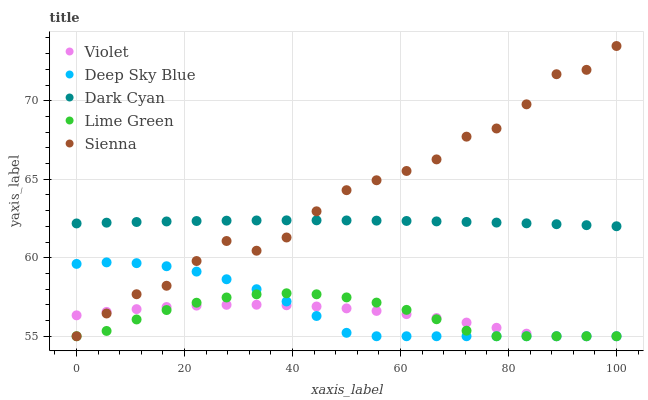Does Violet have the minimum area under the curve?
Answer yes or no. Yes. Does Sienna have the maximum area under the curve?
Answer yes or no. Yes. Does Lime Green have the minimum area under the curve?
Answer yes or no. No. Does Lime Green have the maximum area under the curve?
Answer yes or no. No. Is Dark Cyan the smoothest?
Answer yes or no. Yes. Is Sienna the roughest?
Answer yes or no. Yes. Is Lime Green the smoothest?
Answer yes or no. No. Is Lime Green the roughest?
Answer yes or no. No. Does Sienna have the lowest value?
Answer yes or no. Yes. Does Sienna have the highest value?
Answer yes or no. Yes. Does Lime Green have the highest value?
Answer yes or no. No. Is Deep Sky Blue less than Dark Cyan?
Answer yes or no. Yes. Is Dark Cyan greater than Deep Sky Blue?
Answer yes or no. Yes. Does Dark Cyan intersect Sienna?
Answer yes or no. Yes. Is Dark Cyan less than Sienna?
Answer yes or no. No. Is Dark Cyan greater than Sienna?
Answer yes or no. No. Does Deep Sky Blue intersect Dark Cyan?
Answer yes or no. No. 